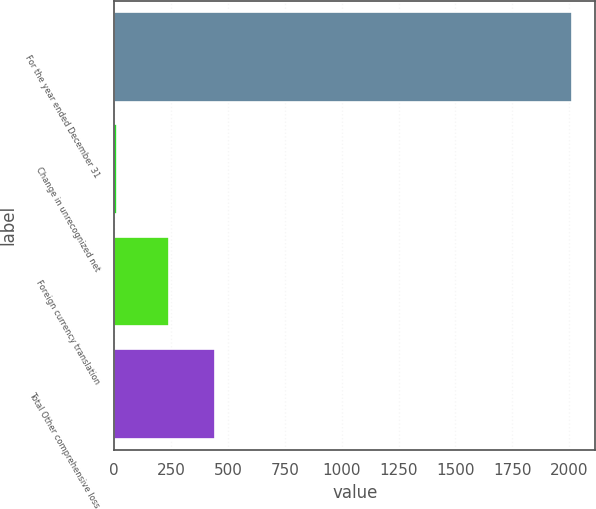Convert chart. <chart><loc_0><loc_0><loc_500><loc_500><bar_chart><fcel>For the year ended December 31<fcel>Change in unrecognized net<fcel>Foreign currency translation<fcel>Total Other comprehensive loss<nl><fcel>2014<fcel>13<fcel>241<fcel>441.1<nl></chart> 